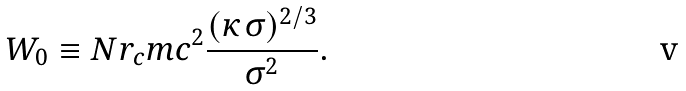Convert formula to latex. <formula><loc_0><loc_0><loc_500><loc_500>W _ { 0 } \equiv N r _ { c } m c ^ { 2 } \frac { ( \kappa \, \sigma ) ^ { 2 / 3 } } { \sigma ^ { 2 } } .</formula> 